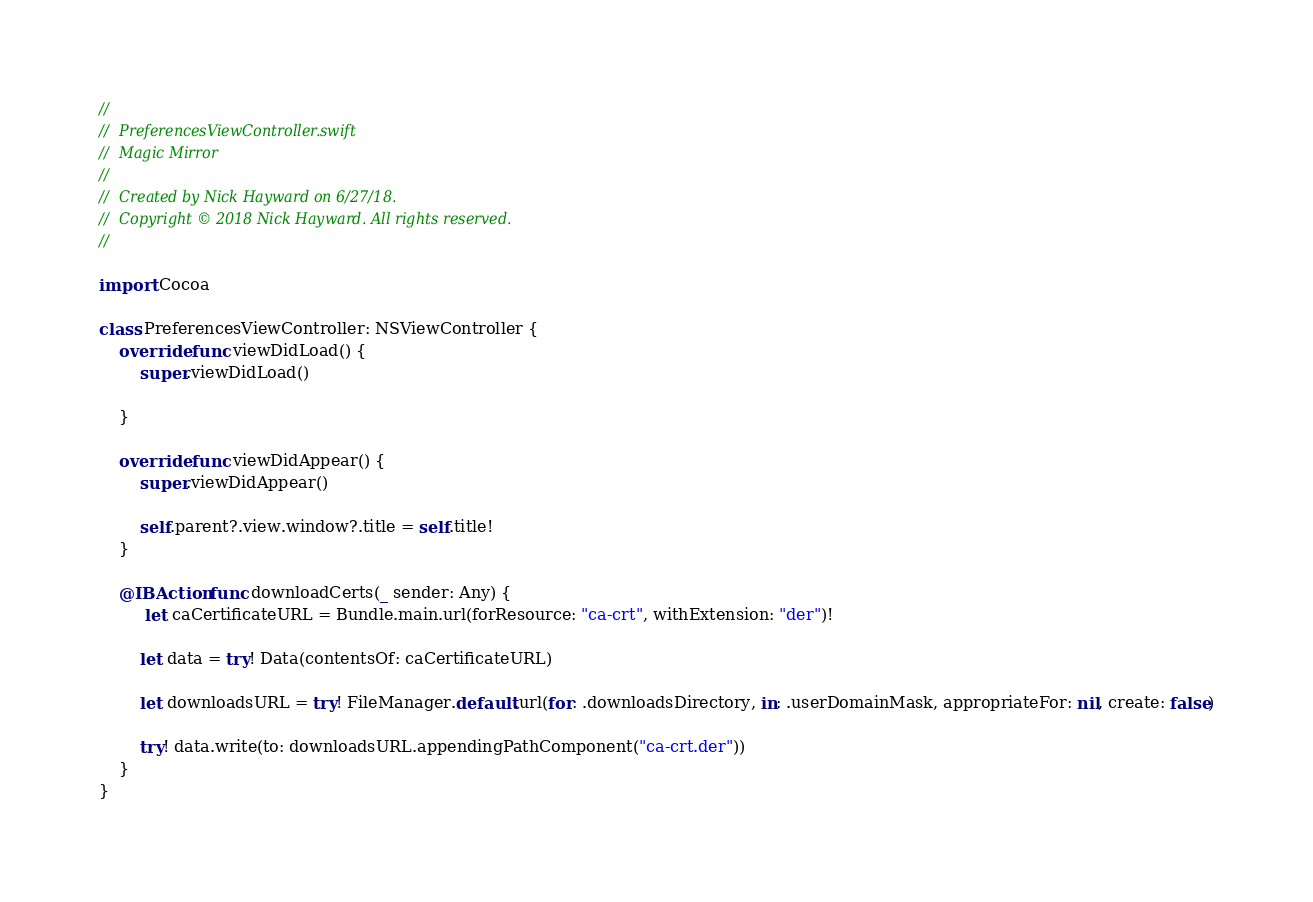Convert code to text. <code><loc_0><loc_0><loc_500><loc_500><_Swift_>//
//  PreferencesViewController.swift
//  Magic Mirror
//
//  Created by Nick Hayward on 6/27/18.
//  Copyright © 2018 Nick Hayward. All rights reserved.
//

import Cocoa

class PreferencesViewController: NSViewController {
    override func viewDidLoad() {
        super.viewDidLoad()
        
    }
    
    override func viewDidAppear() {
        super.viewDidAppear()
        
        self.parent?.view.window?.title = self.title!
    }
    
    @IBAction func downloadCerts(_ sender: Any) {
         let caCertificateURL = Bundle.main.url(forResource: "ca-crt", withExtension: "der")!
    
        let data = try! Data(contentsOf: caCertificateURL)
        
        let downloadsURL = try! FileManager.default.url(for: .downloadsDirectory, in: .userDomainMask, appropriateFor: nil, create: false)
        
        try! data.write(to: downloadsURL.appendingPathComponent("ca-crt.der"))
    }
}
</code> 